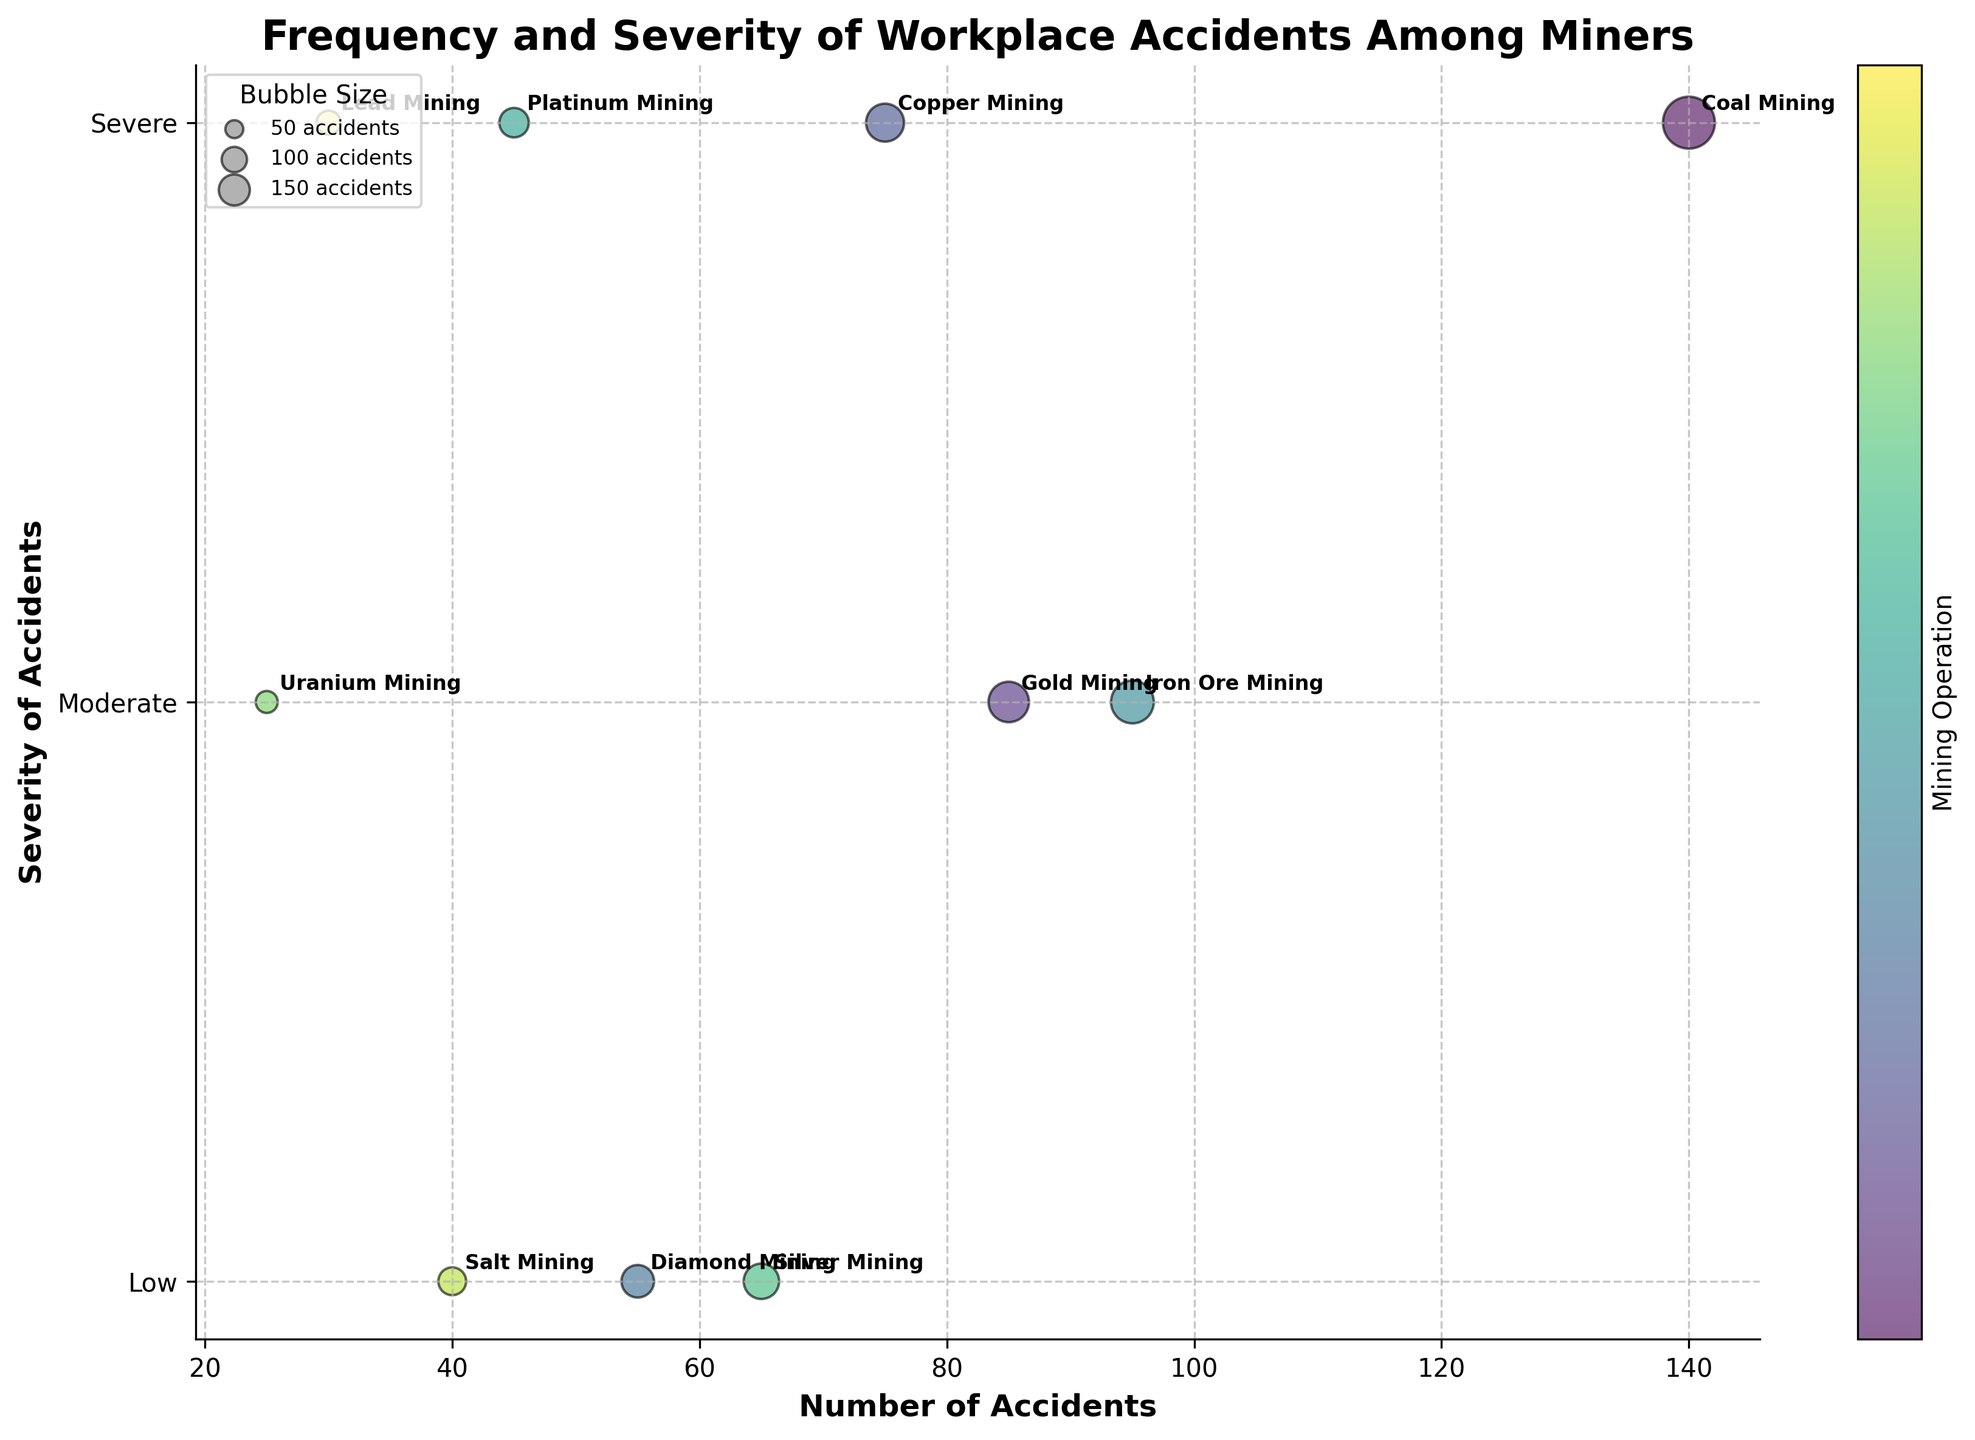What is the title of the plot? The title is usually displayed at the top of the plot. It helps to understand the main subject of the visualization.
Answer: Frequency and Severity of Workplace Accidents Among Miners How many types of mining operations are shown in the plot? By counting the number of distinct bubbles or annotations on the plot, each representing a different mining operation.
Answer: 10 Which mining operation has the highest number of accidents? Identify the bubble with the largest x-value, which corresponds to the number of accidents.
Answer: Coal Mining What is the severity level for Copper Mining? Look at the y-axis value for the bubble labeled 'Copper Mining' and match it to the severity levels displayed on the y-axis.
Answer: Severe Which mining operations have 'Low' severity accidents? Identify all the bubbles located at the y-axis value corresponding to 'Low' severity, and read their labels.
Answer: Diamond Mining, Silver Mining, Salt Mining How does the number of accidents in Uranium Mining compare to Lead Mining? Find the x-values for Uranium Mining and Lead Mining bubbles and compare them.
Answer: Uranium Mining has fewer accidents than Lead Mining Which mining operation in South Africa has the least number of accidents? Locate the bubbles labeled 'South Africa' and compare their x-values to identify the one with the smallest value.
Answer: Platinum Mining What is the size of the bubble for Coal Mining? The bubble size is proportional to the number of accidents, typically visualized by the bubble's area. The exact size parameter in the plot calculation is not directly interpretable from the visual alone. Still, it is generally the largest bubble due to the highest accidents. The exact size parameter would require the formula, but visual estimation shows it is the largest.
Answer: Largest Bubble How does the color scheme help in differentiating the mining operations? The different colors represent distinct types of mining operations, aiding in visually distinguishing between them. The colors are generally gradient variations to help identify each operation more clearly.
Answer: Distinguishes mining types via color gradient 